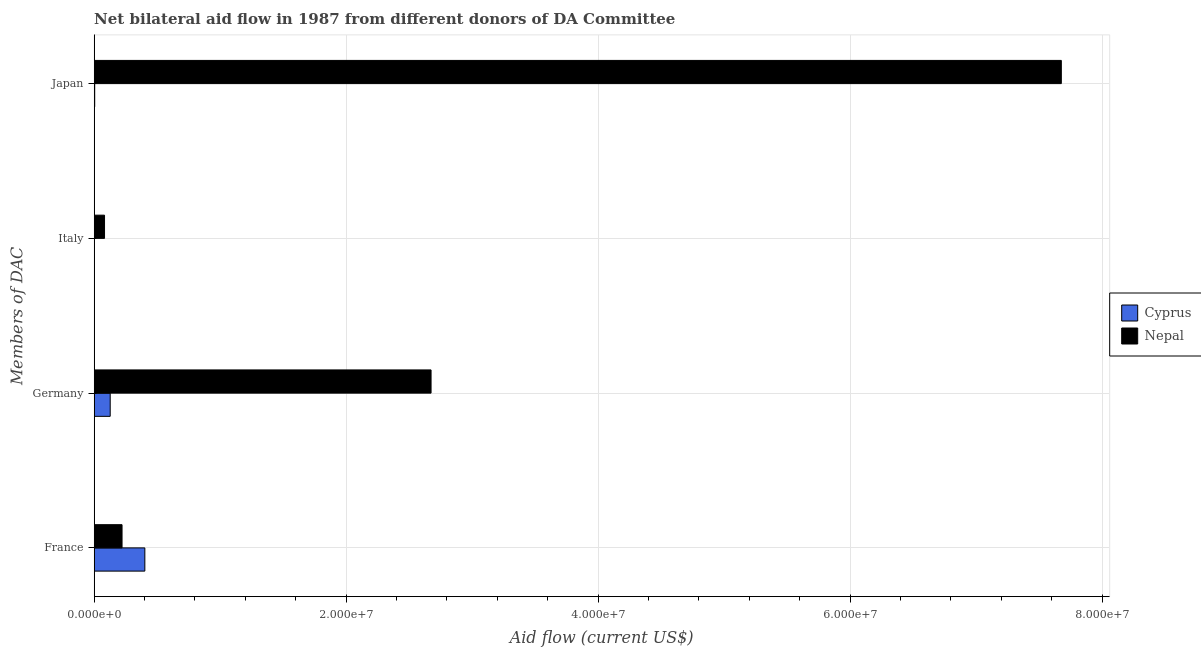Are the number of bars per tick equal to the number of legend labels?
Offer a terse response. Yes. Are the number of bars on each tick of the Y-axis equal?
Make the answer very short. Yes. How many bars are there on the 2nd tick from the top?
Offer a very short reply. 2. How many bars are there on the 2nd tick from the bottom?
Give a very brief answer. 2. What is the amount of aid given by france in Nepal?
Provide a succinct answer. 2.21e+06. Across all countries, what is the maximum amount of aid given by italy?
Give a very brief answer. 8.20e+05. Across all countries, what is the minimum amount of aid given by japan?
Give a very brief answer. 4.00e+04. In which country was the amount of aid given by france maximum?
Offer a very short reply. Cyprus. In which country was the amount of aid given by germany minimum?
Offer a terse response. Cyprus. What is the total amount of aid given by germany in the graph?
Your answer should be very brief. 2.80e+07. What is the difference between the amount of aid given by germany in Nepal and that in Cyprus?
Give a very brief answer. 2.55e+07. What is the difference between the amount of aid given by france in Cyprus and the amount of aid given by germany in Nepal?
Offer a very short reply. -2.27e+07. What is the average amount of aid given by germany per country?
Your answer should be compact. 1.40e+07. What is the difference between the amount of aid given by germany and amount of aid given by italy in Nepal?
Keep it short and to the point. 2.59e+07. In how many countries, is the amount of aid given by germany greater than 8000000 US$?
Ensure brevity in your answer.  1. What is the ratio of the amount of aid given by italy in Nepal to that in Cyprus?
Offer a terse response. 82. Is the amount of aid given by italy in Cyprus less than that in Nepal?
Offer a terse response. Yes. What is the difference between the highest and the second highest amount of aid given by japan?
Your answer should be compact. 7.67e+07. What is the difference between the highest and the lowest amount of aid given by japan?
Provide a short and direct response. 7.67e+07. In how many countries, is the amount of aid given by japan greater than the average amount of aid given by japan taken over all countries?
Offer a very short reply. 1. Is the sum of the amount of aid given by france in Cyprus and Nepal greater than the maximum amount of aid given by italy across all countries?
Ensure brevity in your answer.  Yes. Is it the case that in every country, the sum of the amount of aid given by italy and amount of aid given by france is greater than the sum of amount of aid given by japan and amount of aid given by germany?
Your answer should be compact. No. What does the 2nd bar from the top in France represents?
Your answer should be compact. Cyprus. What does the 1st bar from the bottom in Japan represents?
Provide a succinct answer. Cyprus. How many bars are there?
Offer a terse response. 8. What is the difference between two consecutive major ticks on the X-axis?
Ensure brevity in your answer.  2.00e+07. Where does the legend appear in the graph?
Ensure brevity in your answer.  Center right. How many legend labels are there?
Provide a succinct answer. 2. How are the legend labels stacked?
Provide a short and direct response. Vertical. What is the title of the graph?
Ensure brevity in your answer.  Net bilateral aid flow in 1987 from different donors of DA Committee. What is the label or title of the Y-axis?
Your response must be concise. Members of DAC. What is the Aid flow (current US$) in Cyprus in France?
Make the answer very short. 4.02e+06. What is the Aid flow (current US$) of Nepal in France?
Your response must be concise. 2.21e+06. What is the Aid flow (current US$) in Cyprus in Germany?
Your answer should be very brief. 1.27e+06. What is the Aid flow (current US$) in Nepal in Germany?
Provide a succinct answer. 2.67e+07. What is the Aid flow (current US$) in Nepal in Italy?
Ensure brevity in your answer.  8.20e+05. What is the Aid flow (current US$) in Cyprus in Japan?
Give a very brief answer. 4.00e+04. What is the Aid flow (current US$) of Nepal in Japan?
Your answer should be very brief. 7.68e+07. Across all Members of DAC, what is the maximum Aid flow (current US$) in Cyprus?
Offer a very short reply. 4.02e+06. Across all Members of DAC, what is the maximum Aid flow (current US$) of Nepal?
Offer a terse response. 7.68e+07. Across all Members of DAC, what is the minimum Aid flow (current US$) in Nepal?
Make the answer very short. 8.20e+05. What is the total Aid flow (current US$) of Cyprus in the graph?
Provide a short and direct response. 5.34e+06. What is the total Aid flow (current US$) in Nepal in the graph?
Offer a terse response. 1.07e+08. What is the difference between the Aid flow (current US$) in Cyprus in France and that in Germany?
Your answer should be very brief. 2.75e+06. What is the difference between the Aid flow (current US$) of Nepal in France and that in Germany?
Your response must be concise. -2.45e+07. What is the difference between the Aid flow (current US$) in Cyprus in France and that in Italy?
Make the answer very short. 4.01e+06. What is the difference between the Aid flow (current US$) in Nepal in France and that in Italy?
Offer a very short reply. 1.39e+06. What is the difference between the Aid flow (current US$) of Cyprus in France and that in Japan?
Your answer should be very brief. 3.98e+06. What is the difference between the Aid flow (current US$) of Nepal in France and that in Japan?
Keep it short and to the point. -7.46e+07. What is the difference between the Aid flow (current US$) of Cyprus in Germany and that in Italy?
Give a very brief answer. 1.26e+06. What is the difference between the Aid flow (current US$) of Nepal in Germany and that in Italy?
Provide a short and direct response. 2.59e+07. What is the difference between the Aid flow (current US$) of Cyprus in Germany and that in Japan?
Make the answer very short. 1.23e+06. What is the difference between the Aid flow (current US$) of Nepal in Germany and that in Japan?
Make the answer very short. -5.00e+07. What is the difference between the Aid flow (current US$) of Nepal in Italy and that in Japan?
Ensure brevity in your answer.  -7.60e+07. What is the difference between the Aid flow (current US$) in Cyprus in France and the Aid flow (current US$) in Nepal in Germany?
Keep it short and to the point. -2.27e+07. What is the difference between the Aid flow (current US$) in Cyprus in France and the Aid flow (current US$) in Nepal in Italy?
Make the answer very short. 3.20e+06. What is the difference between the Aid flow (current US$) of Cyprus in France and the Aid flow (current US$) of Nepal in Japan?
Keep it short and to the point. -7.28e+07. What is the difference between the Aid flow (current US$) of Cyprus in Germany and the Aid flow (current US$) of Nepal in Japan?
Provide a succinct answer. -7.55e+07. What is the difference between the Aid flow (current US$) in Cyprus in Italy and the Aid flow (current US$) in Nepal in Japan?
Your answer should be compact. -7.68e+07. What is the average Aid flow (current US$) of Cyprus per Members of DAC?
Provide a succinct answer. 1.34e+06. What is the average Aid flow (current US$) in Nepal per Members of DAC?
Provide a succinct answer. 2.66e+07. What is the difference between the Aid flow (current US$) of Cyprus and Aid flow (current US$) of Nepal in France?
Ensure brevity in your answer.  1.81e+06. What is the difference between the Aid flow (current US$) of Cyprus and Aid flow (current US$) of Nepal in Germany?
Provide a succinct answer. -2.55e+07. What is the difference between the Aid flow (current US$) in Cyprus and Aid flow (current US$) in Nepal in Italy?
Your answer should be very brief. -8.10e+05. What is the difference between the Aid flow (current US$) in Cyprus and Aid flow (current US$) in Nepal in Japan?
Provide a short and direct response. -7.67e+07. What is the ratio of the Aid flow (current US$) of Cyprus in France to that in Germany?
Your answer should be compact. 3.17. What is the ratio of the Aid flow (current US$) of Nepal in France to that in Germany?
Give a very brief answer. 0.08. What is the ratio of the Aid flow (current US$) of Cyprus in France to that in Italy?
Make the answer very short. 402. What is the ratio of the Aid flow (current US$) in Nepal in France to that in Italy?
Provide a short and direct response. 2.7. What is the ratio of the Aid flow (current US$) of Cyprus in France to that in Japan?
Give a very brief answer. 100.5. What is the ratio of the Aid flow (current US$) in Nepal in France to that in Japan?
Keep it short and to the point. 0.03. What is the ratio of the Aid flow (current US$) of Cyprus in Germany to that in Italy?
Give a very brief answer. 127. What is the ratio of the Aid flow (current US$) of Nepal in Germany to that in Italy?
Provide a succinct answer. 32.61. What is the ratio of the Aid flow (current US$) in Cyprus in Germany to that in Japan?
Make the answer very short. 31.75. What is the ratio of the Aid flow (current US$) in Nepal in Germany to that in Japan?
Your response must be concise. 0.35. What is the ratio of the Aid flow (current US$) in Cyprus in Italy to that in Japan?
Offer a terse response. 0.25. What is the ratio of the Aid flow (current US$) in Nepal in Italy to that in Japan?
Provide a succinct answer. 0.01. What is the difference between the highest and the second highest Aid flow (current US$) of Cyprus?
Provide a short and direct response. 2.75e+06. What is the difference between the highest and the second highest Aid flow (current US$) of Nepal?
Your response must be concise. 5.00e+07. What is the difference between the highest and the lowest Aid flow (current US$) of Cyprus?
Offer a very short reply. 4.01e+06. What is the difference between the highest and the lowest Aid flow (current US$) in Nepal?
Make the answer very short. 7.60e+07. 